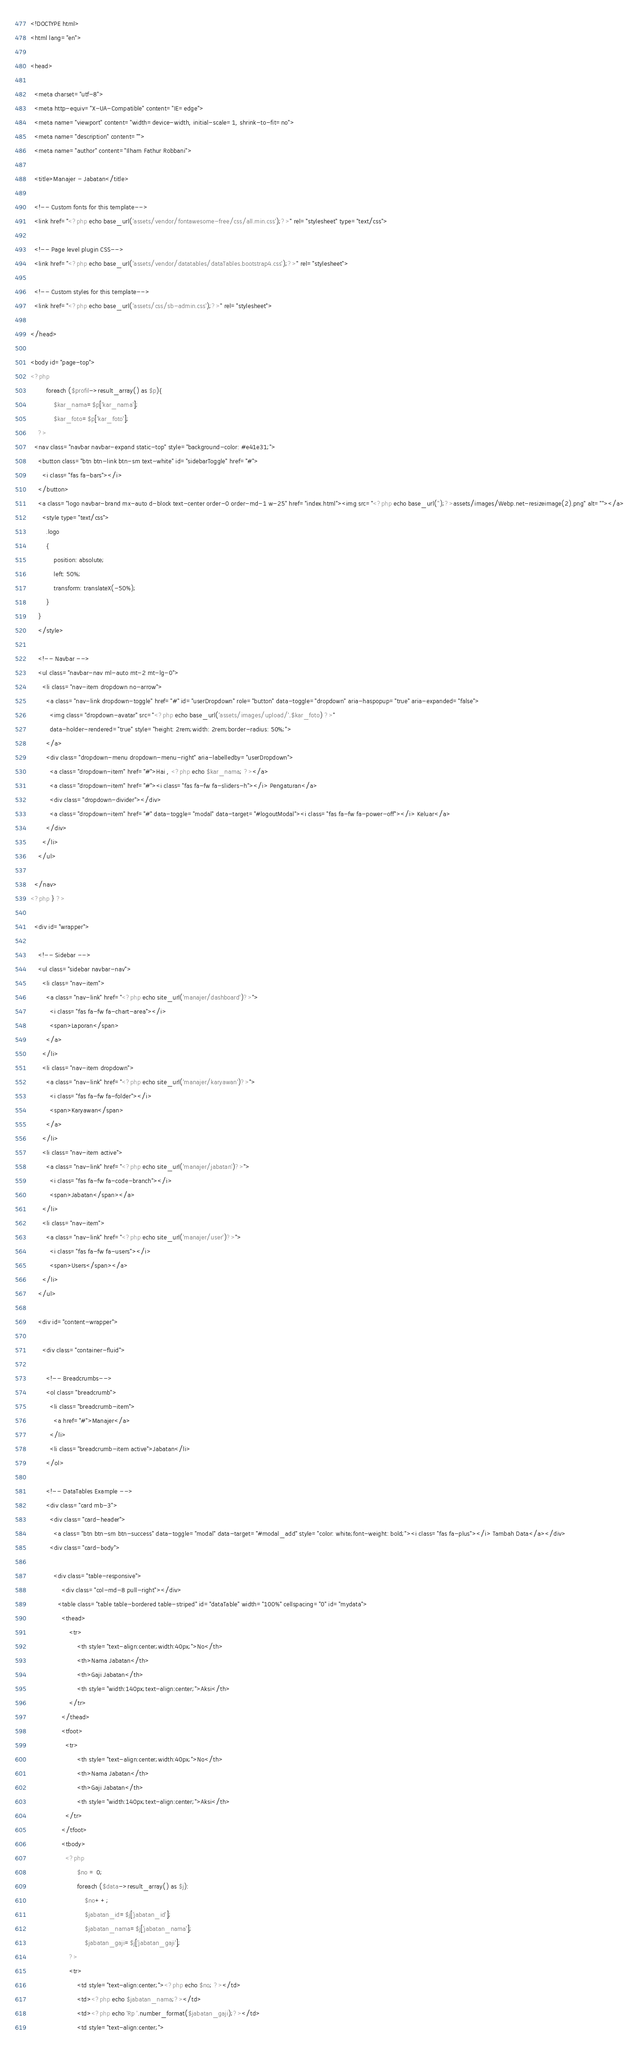Convert code to text. <code><loc_0><loc_0><loc_500><loc_500><_PHP_><!DOCTYPE html>
<html lang="en">

<head>

  <meta charset="utf-8">
  <meta http-equiv="X-UA-Compatible" content="IE=edge">
  <meta name="viewport" content="width=device-width, initial-scale=1, shrink-to-fit=no">
  <meta name="description" content="">
  <meta name="author" content="Ilham Fathur Robbani">

  <title>Manajer - Jabatan</title>

  <!-- Custom fonts for this template-->
  <link href="<?php echo base_url('assets/vendor/fontawesome-free/css/all.min.css');?>" rel="stylesheet" type="text/css">

  <!-- Page level plugin CSS-->
  <link href="<?php echo base_url('assets/vendor/datatables/dataTables.bootstrap4.css');?>" rel="stylesheet">

  <!-- Custom styles for this template-->
  <link href="<?php echo base_url('assets/css/sb-admin.css');?>" rel="stylesheet">

</head>

<body id="page-top">
<?php
        foreach ($profil->result_array() as $p){
            $kar_nama=$p['kar_nama'];
            $kar_foto=$p['kar_foto'];
    ?>  
  <nav class="navbar navbar-expand static-top" style="background-color: #e41e31;">
    <button class="btn btn-link btn-sm text-white" id="sidebarToggle" href="#">
      <i class="fas fa-bars"></i>
    </button>
    <a class="logo navbar-brand mx-auto d-block text-center order-0 order-md-1 w-25" href="index.html"><img src="<?php echo base_url('');?>assets/images/Webp.net-resizeimage(2).png" alt=""></a>
      <style type="text/css">
        .logo
        {
            position: absolute;
            left: 50%;
            transform: translateX(-50%);
        }
    }
    </style>

    <!-- Navbar -->
    <ul class="navbar-nav ml-auto mt-2 mt-lg-0">
      <li class="nav-item dropdown no-arrow">
        <a class="nav-link dropdown-toggle" href="#" id="userDropdown" role="button" data-toggle="dropdown" aria-haspopup="true" aria-expanded="false">
          <img class="dropdown-avatar" src="<?php echo base_url('assets/images/upload/'.$kar_foto) ?>"
          data-holder-rendered="true" style="height: 2rem;width: 2rem;border-radius: 50%;">
        </a>
        <div class="dropdown-menu dropdown-menu-right" aria-labelledby="userDropdown">
          <a class="dropdown-item" href="#">Hai , <?php echo $kar_nama; ?></a>
          <a class="dropdown-item" href="#"><i class="fas fa-fw fa-sliders-h"></i> Pengaturan</a>
          <div class="dropdown-divider"></div>
          <a class="dropdown-item" href="#" data-toggle="modal" data-target="#logoutModal"><i class="fas fa-fw fa-power-off"></i> Keluar</a>
        </div>
      </li>
    </ul>

  </nav>
<?php } ?>

  <div id="wrapper">

    <!-- Sidebar -->
    <ul class="sidebar navbar-nav">
      <li class="nav-item">
        <a class="nav-link" href="<?php echo site_url('manajer/dashboard')?>">
          <i class="fas fa-fw fa-chart-area"></i>
          <span>Laporan</span>
        </a>
      </li>
      <li class="nav-item dropdown">
        <a class="nav-link" href="<?php echo site_url('manajer/karyawan')?>">
          <i class="fas fa-fw fa-folder"></i>
          <span>Karyawan</span>
        </a>
      </li>
      <li class="nav-item active">
        <a class="nav-link" href="<?php echo site_url('manajer/jabatan')?>">
          <i class="fas fa-fw fa-code-branch"></i>
          <span>Jabatan</span></a>
      </li>
      <li class="nav-item">
        <a class="nav-link" href="<?php echo site_url('manajer/user')?>">
          <i class="fas fa-fw fa-users"></i>
          <span>Users</span></a>
      </li>
    </ul>

    <div id="content-wrapper">

      <div class="container-fluid">

        <!-- Breadcrumbs-->
        <ol class="breadcrumb">
          <li class="breadcrumb-item">
            <a href="#">Manajer</a>
          </li>
          <li class="breadcrumb-item active">Jabatan</li>
        </ol>

        <!-- DataTables Example -->
        <div class="card mb-3">
          <div class="card-header">
            <a class="btn btn-sm btn-success" data-toggle="modal" data-target="#modal_add" style="color: white;font-weight: bold;"><i class="fas fa-plus"></i> Tambah Data</a></div>
          <div class="card-body">

            <div class="table-responsive">
                <div class="col-md-8 pull-right"></div>
              <table class="table table-bordered table-striped" id="dataTable" width="100%" cellspacing="0" id="mydata">
                <thead>
                    <tr>
                        <th style="text-align:center;width:40px;">No</th>
                        <th>Nama Jabatan</th>
                        <th>Gaji Jabatan</th>
                        <th style="width:140px;text-align:center;">Aksi</th>
                    </tr>
                </thead>
                <tfoot>
                  <tr>
                        <th style="text-align:center;width:40px;">No</th>
                        <th>Nama Jabatan</th>
                        <th>Gaji Jabatan</th>
                        <th style="width:140px;text-align:center;">Aksi</th>
                  </tr>
                </tfoot>
                <tbody>
                  <?php
                        $no = 0;
                        foreach ($data->result_array() as $j):
                            $no++;
                            $jabatan_id=$j['jabatan_id'];
                            $jabatan_nama=$j['jabatan_nama'];
                            $jabatan_gaji=$j['jabatan_gaji'];
                    ?>
                    <tr>
                        <td style="text-align:center;"><?php echo $no; ?></td>
                        <td><?php echo $jabatan_nama;?></td>
                        <td><?php echo 'Rp '.number_format($jabatan_gaji);?></td>
                        <td style="text-align:center;"></code> 